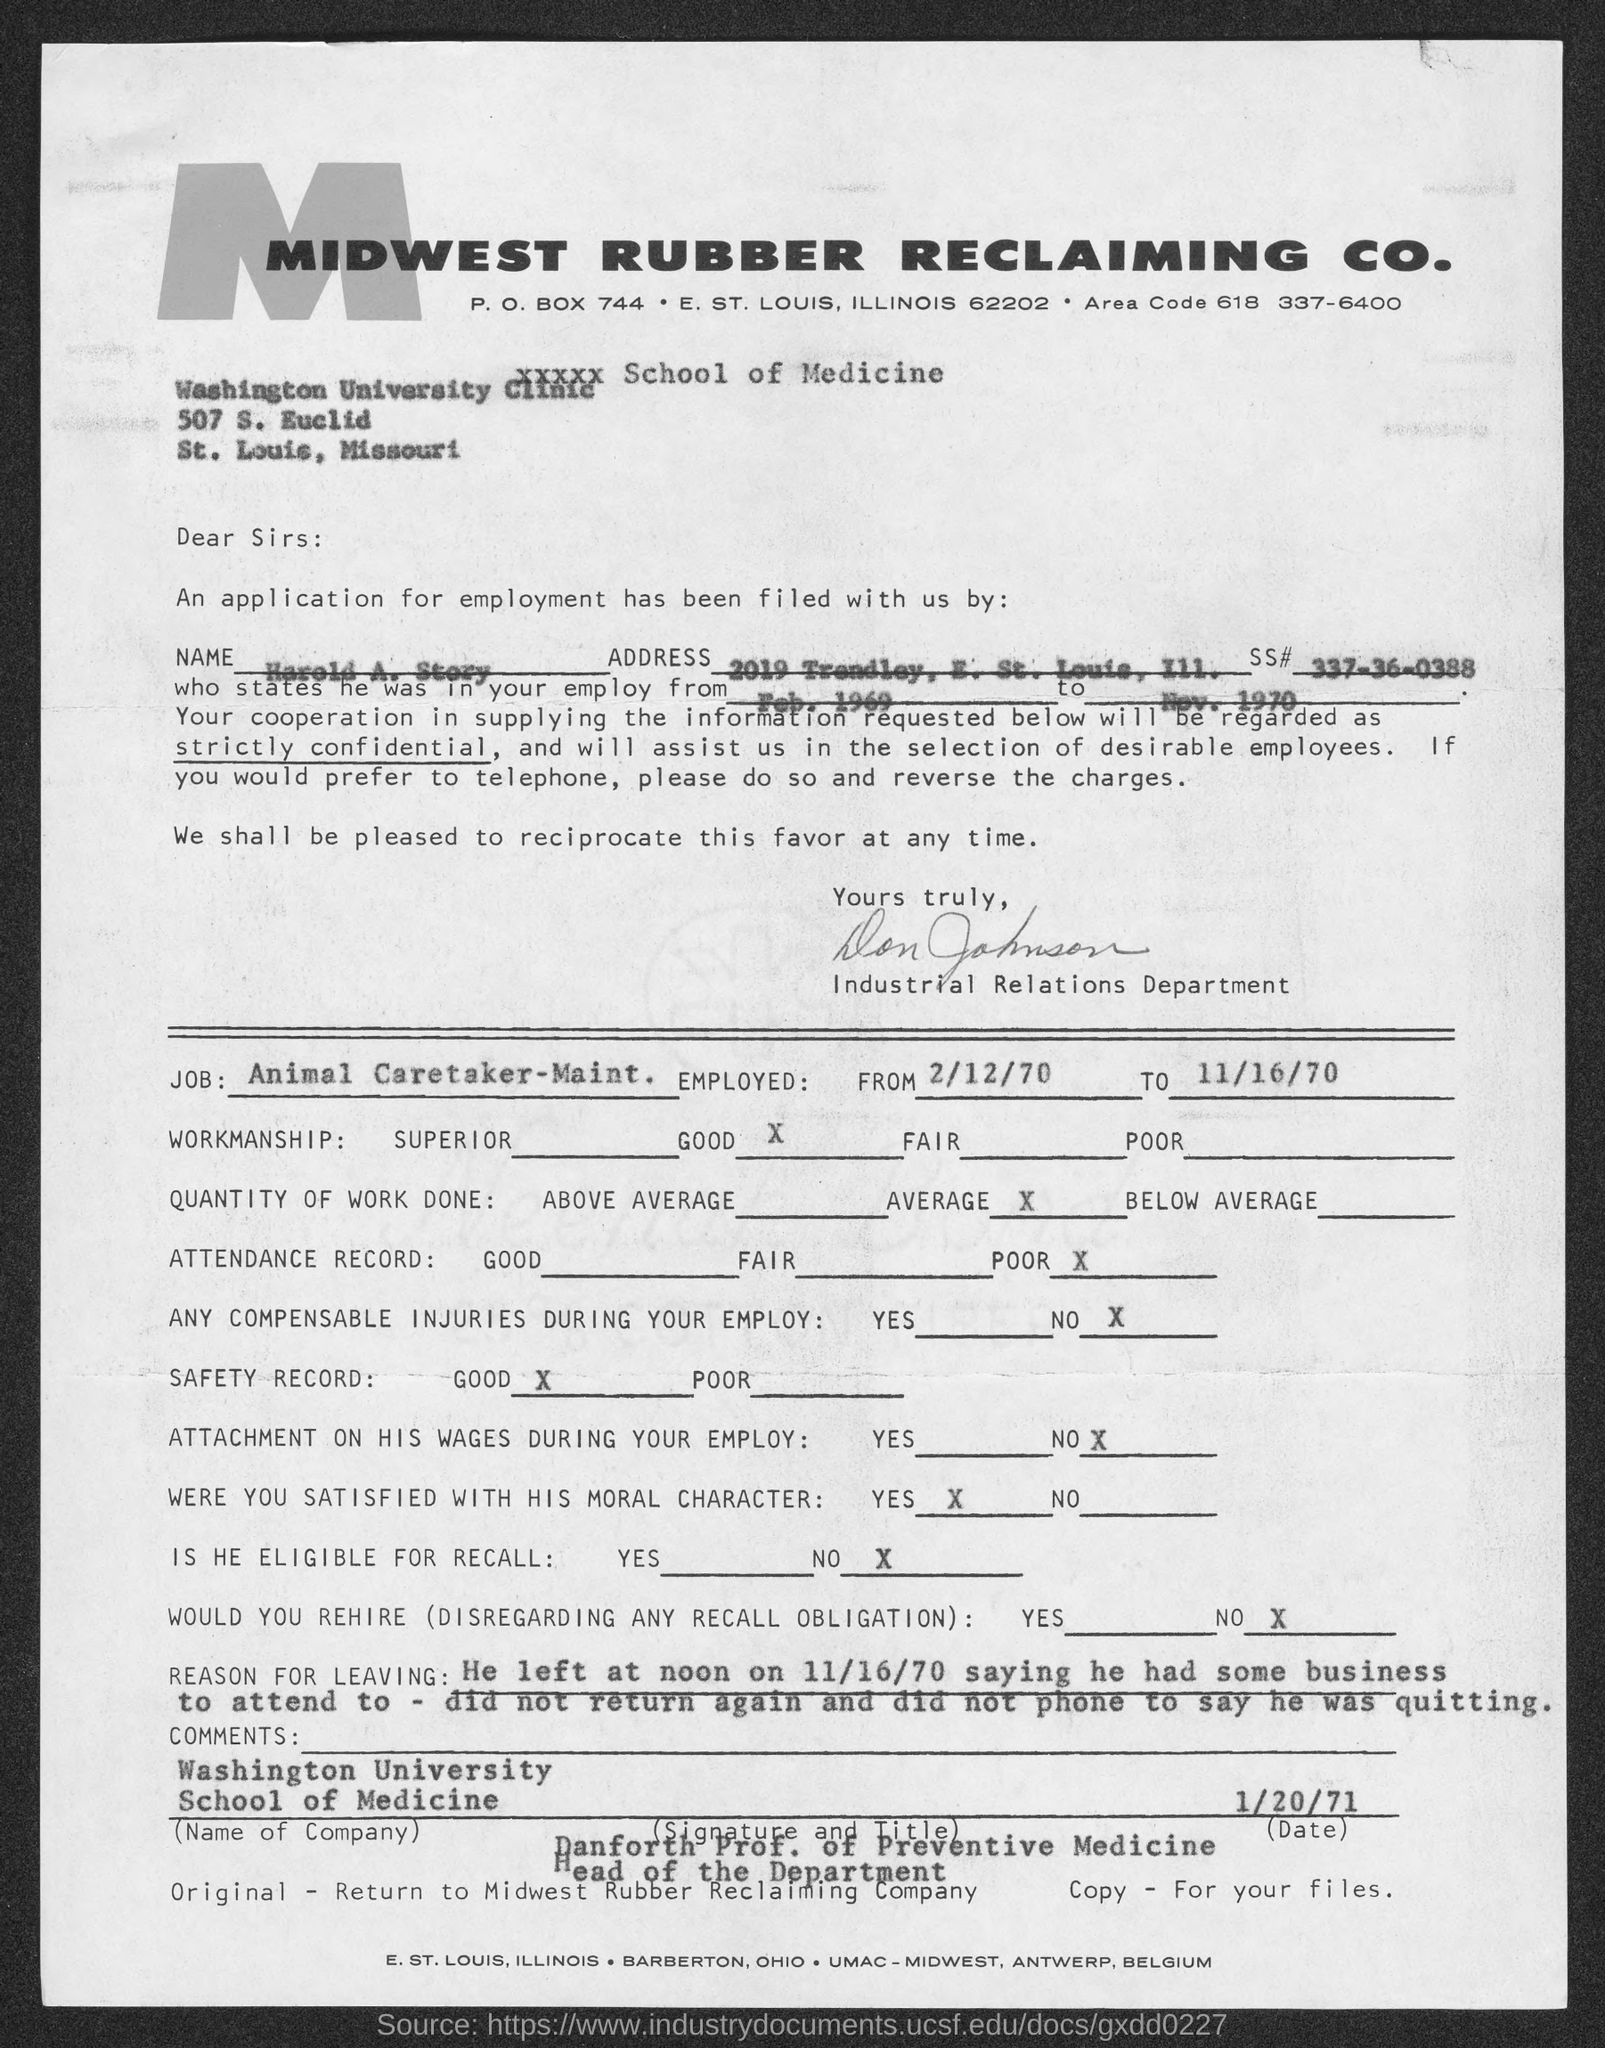Specify some key components in this picture. The Social Security number of the applicant is 337-36-0388. The applicant's name is Harold A. Story. The area code is 618. The P.O. box number of Midwest Rubber Reclaiming Co. is P.O. Box 744. 